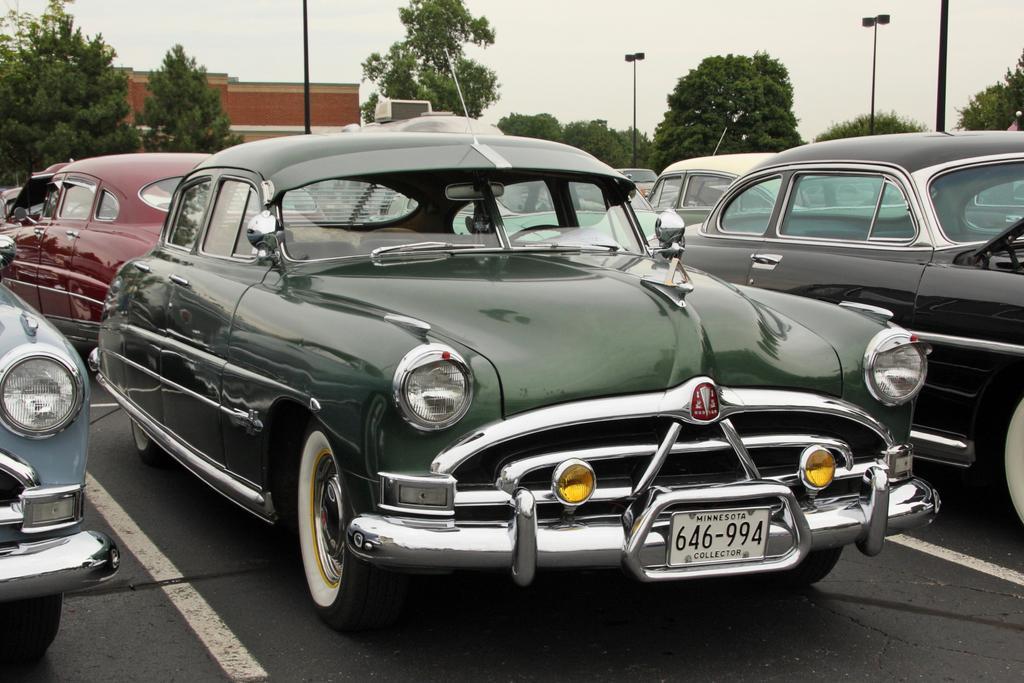How would you summarize this image in a sentence or two? In this image I can see few cars and the building wall and poles and trees and the sky at the top. 